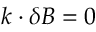<formula> <loc_0><loc_0><loc_500><loc_500>k \cdot \delta B = 0</formula> 